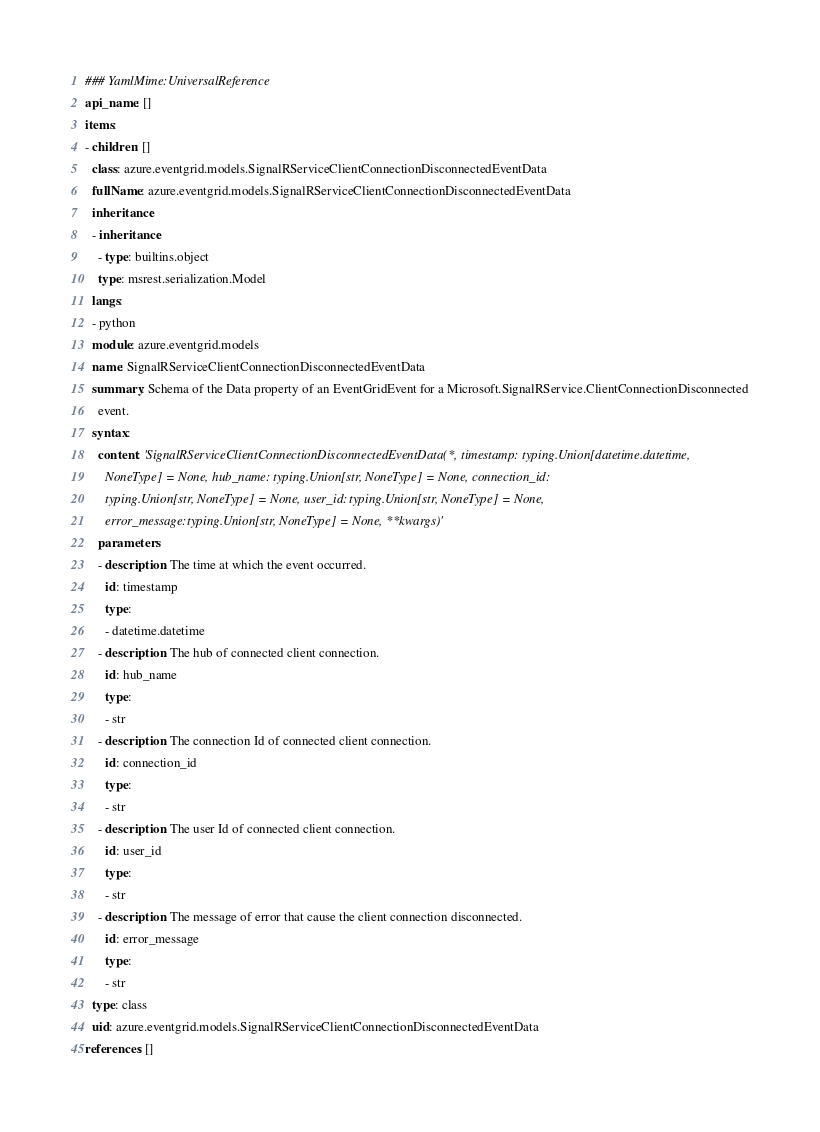Convert code to text. <code><loc_0><loc_0><loc_500><loc_500><_YAML_>### YamlMime:UniversalReference
api_name: []
items:
- children: []
  class: azure.eventgrid.models.SignalRServiceClientConnectionDisconnectedEventData
  fullName: azure.eventgrid.models.SignalRServiceClientConnectionDisconnectedEventData
  inheritance:
  - inheritance:
    - type: builtins.object
    type: msrest.serialization.Model
  langs:
  - python
  module: azure.eventgrid.models
  name: SignalRServiceClientConnectionDisconnectedEventData
  summary: Schema of the Data property of an EventGridEvent for a Microsoft.SignalRService.ClientConnectionDisconnected
    event.
  syntax:
    content: 'SignalRServiceClientConnectionDisconnectedEventData(*, timestamp: typing.Union[datetime.datetime,
      NoneType] = None, hub_name: typing.Union[str, NoneType] = None, connection_id:
      typing.Union[str, NoneType] = None, user_id: typing.Union[str, NoneType] = None,
      error_message: typing.Union[str, NoneType] = None, **kwargs)'
    parameters:
    - description: The time at which the event occurred.
      id: timestamp
      type:
      - datetime.datetime
    - description: The hub of connected client connection.
      id: hub_name
      type:
      - str
    - description: The connection Id of connected client connection.
      id: connection_id
      type:
      - str
    - description: The user Id of connected client connection.
      id: user_id
      type:
      - str
    - description: The message of error that cause the client connection disconnected.
      id: error_message
      type:
      - str
  type: class
  uid: azure.eventgrid.models.SignalRServiceClientConnectionDisconnectedEventData
references: []
</code> 